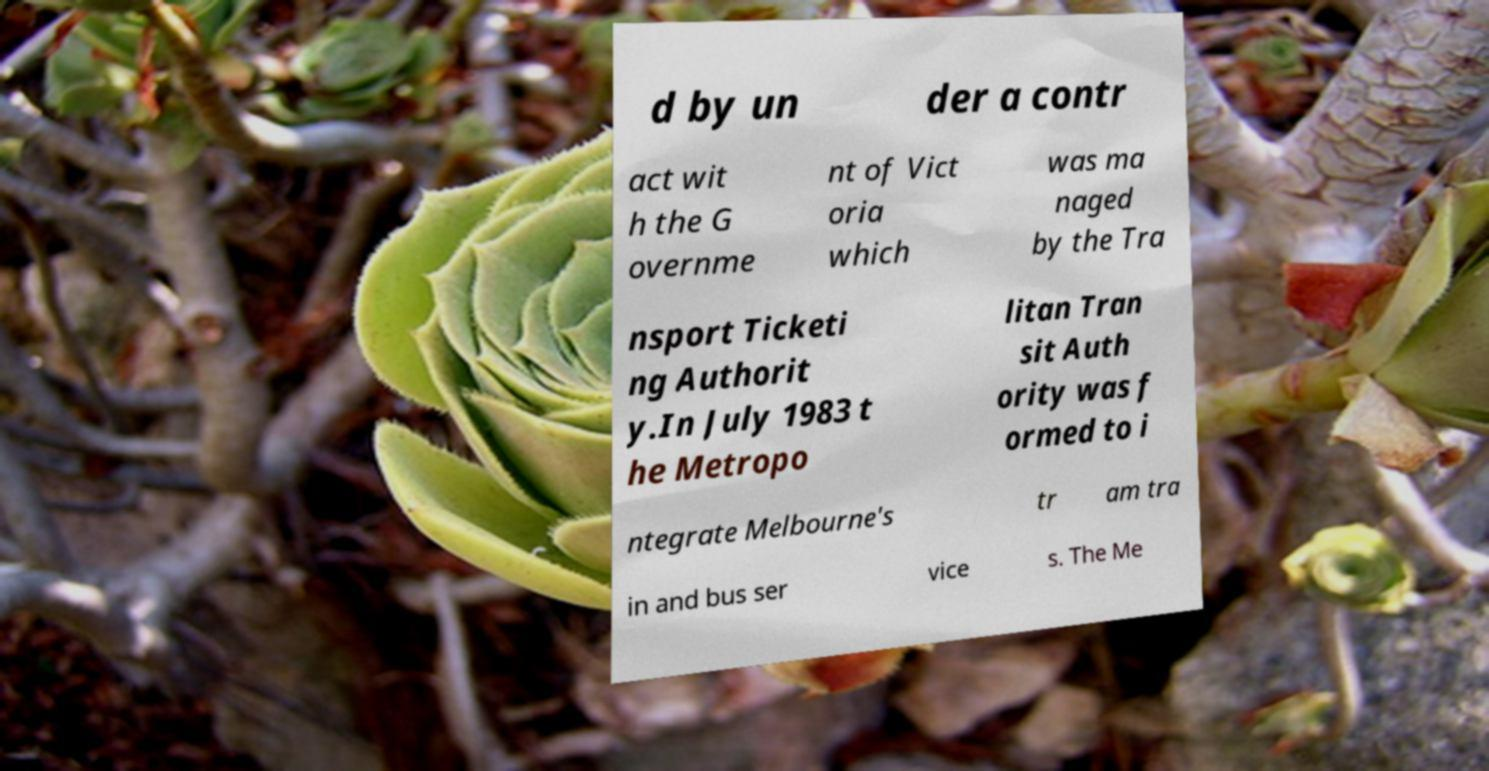I need the written content from this picture converted into text. Can you do that? d by un der a contr act wit h the G overnme nt of Vict oria which was ma naged by the Tra nsport Ticketi ng Authorit y.In July 1983 t he Metropo litan Tran sit Auth ority was f ormed to i ntegrate Melbourne's tr am tra in and bus ser vice s. The Me 